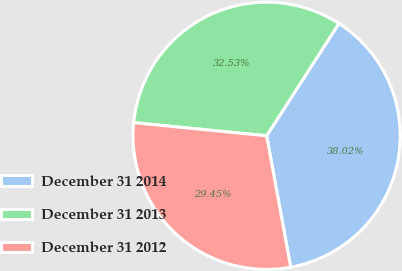<chart> <loc_0><loc_0><loc_500><loc_500><pie_chart><fcel>December 31 2014<fcel>December 31 2013<fcel>December 31 2012<nl><fcel>38.02%<fcel>32.53%<fcel>29.45%<nl></chart> 